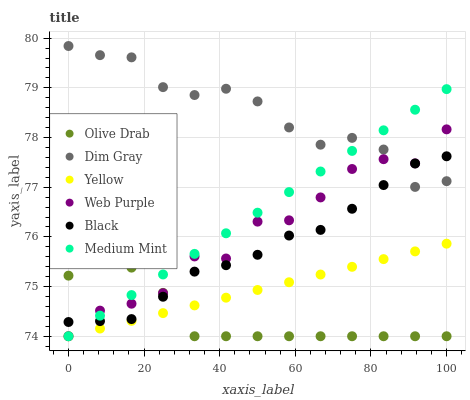Does Olive Drab have the minimum area under the curve?
Answer yes or no. Yes. Does Dim Gray have the maximum area under the curve?
Answer yes or no. Yes. Does Yellow have the minimum area under the curve?
Answer yes or no. No. Does Yellow have the maximum area under the curve?
Answer yes or no. No. Is Yellow the smoothest?
Answer yes or no. Yes. Is Web Purple the roughest?
Answer yes or no. Yes. Is Dim Gray the smoothest?
Answer yes or no. No. Is Dim Gray the roughest?
Answer yes or no. No. Does Medium Mint have the lowest value?
Answer yes or no. Yes. Does Dim Gray have the lowest value?
Answer yes or no. No. Does Dim Gray have the highest value?
Answer yes or no. Yes. Does Yellow have the highest value?
Answer yes or no. No. Is Olive Drab less than Dim Gray?
Answer yes or no. Yes. Is Dim Gray greater than Yellow?
Answer yes or no. Yes. Does Medium Mint intersect Olive Drab?
Answer yes or no. Yes. Is Medium Mint less than Olive Drab?
Answer yes or no. No. Is Medium Mint greater than Olive Drab?
Answer yes or no. No. Does Olive Drab intersect Dim Gray?
Answer yes or no. No. 